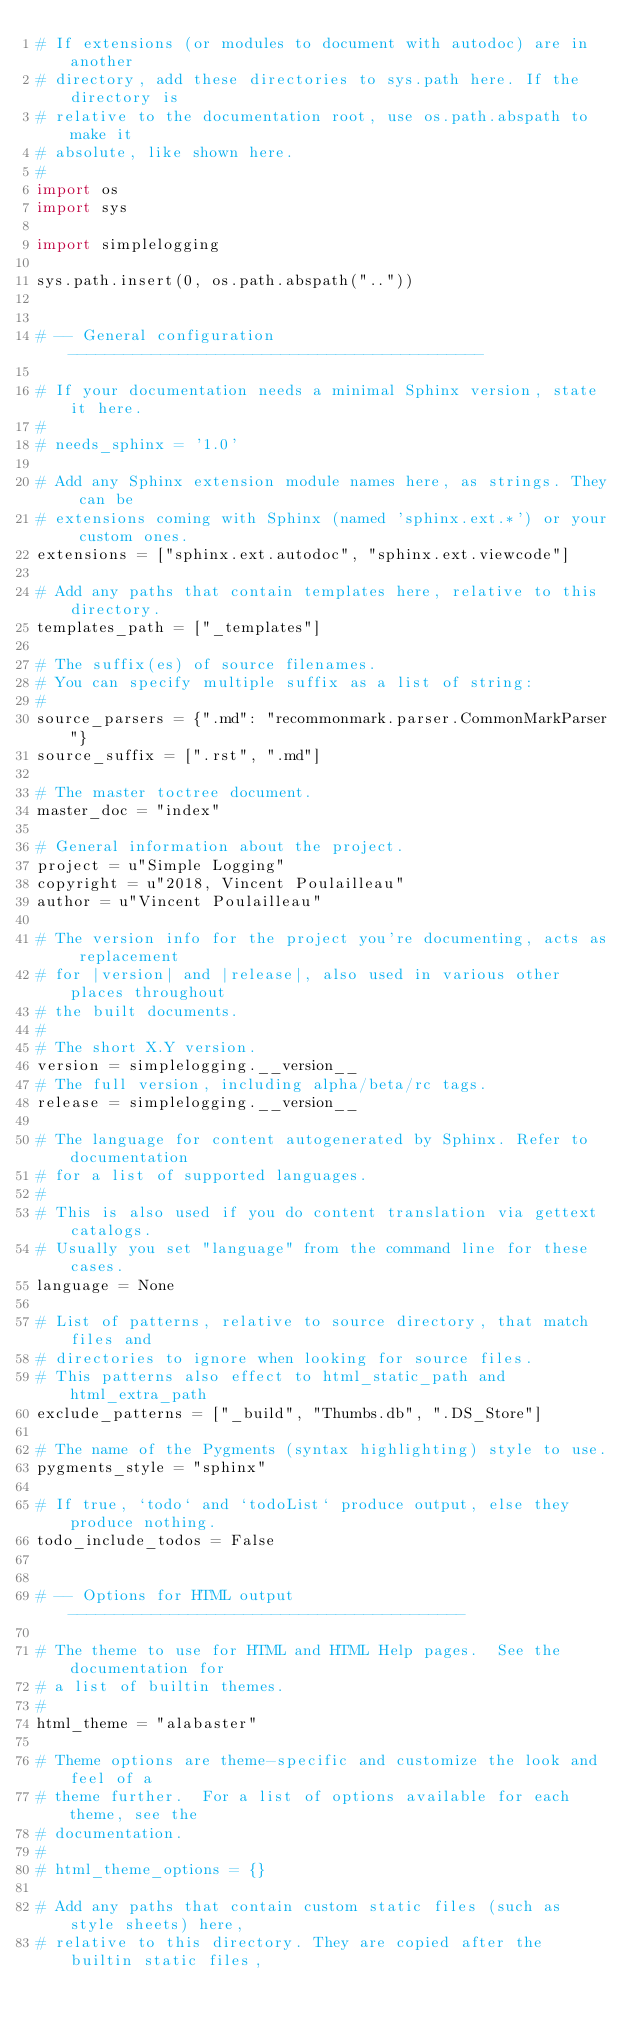Convert code to text. <code><loc_0><loc_0><loc_500><loc_500><_Python_># If extensions (or modules to document with autodoc) are in another
# directory, add these directories to sys.path here. If the directory is
# relative to the documentation root, use os.path.abspath to make it
# absolute, like shown here.
#
import os
import sys

import simplelogging

sys.path.insert(0, os.path.abspath(".."))


# -- General configuration ---------------------------------------------

# If your documentation needs a minimal Sphinx version, state it here.
#
# needs_sphinx = '1.0'

# Add any Sphinx extension module names here, as strings. They can be
# extensions coming with Sphinx (named 'sphinx.ext.*') or your custom ones.
extensions = ["sphinx.ext.autodoc", "sphinx.ext.viewcode"]

# Add any paths that contain templates here, relative to this directory.
templates_path = ["_templates"]

# The suffix(es) of source filenames.
# You can specify multiple suffix as a list of string:
#
source_parsers = {".md": "recommonmark.parser.CommonMarkParser"}
source_suffix = [".rst", ".md"]

# The master toctree document.
master_doc = "index"

# General information about the project.
project = u"Simple Logging"
copyright = u"2018, Vincent Poulailleau"
author = u"Vincent Poulailleau"

# The version info for the project you're documenting, acts as replacement
# for |version| and |release|, also used in various other places throughout
# the built documents.
#
# The short X.Y version.
version = simplelogging.__version__
# The full version, including alpha/beta/rc tags.
release = simplelogging.__version__

# The language for content autogenerated by Sphinx. Refer to documentation
# for a list of supported languages.
#
# This is also used if you do content translation via gettext catalogs.
# Usually you set "language" from the command line for these cases.
language = None

# List of patterns, relative to source directory, that match files and
# directories to ignore when looking for source files.
# This patterns also effect to html_static_path and html_extra_path
exclude_patterns = ["_build", "Thumbs.db", ".DS_Store"]

# The name of the Pygments (syntax highlighting) style to use.
pygments_style = "sphinx"

# If true, `todo` and `todoList` produce output, else they produce nothing.
todo_include_todos = False


# -- Options for HTML output -------------------------------------------

# The theme to use for HTML and HTML Help pages.  See the documentation for
# a list of builtin themes.
#
html_theme = "alabaster"

# Theme options are theme-specific and customize the look and feel of a
# theme further.  For a list of options available for each theme, see the
# documentation.
#
# html_theme_options = {}

# Add any paths that contain custom static files (such as style sheets) here,
# relative to this directory. They are copied after the builtin static files,</code> 